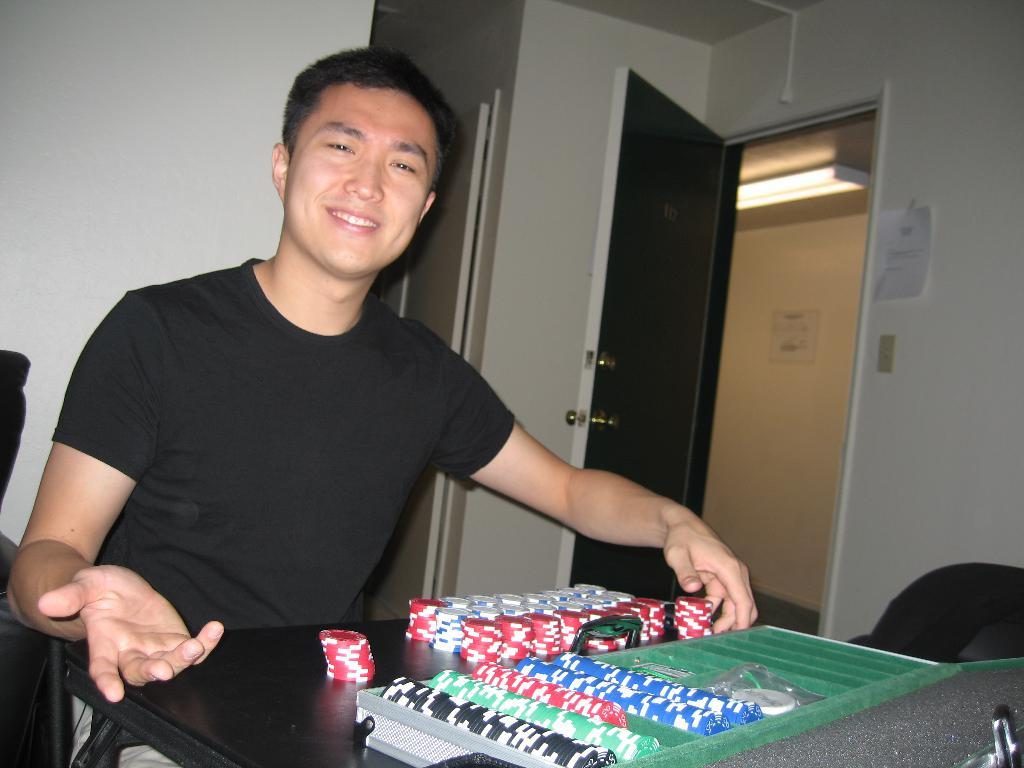Who is present in the image? There is a man in the image. What is the man doing in the image? The man is sitting and smiling. What can be seen on the table in the image? There are objects on the table. What is visible in the background of the image? There is a door and a wall visible in the image. What type of leather is visible on the man's apparel in the image? There is no leather visible on the man's apparel in the image. What type of vessel is present on the table in the image? There is no vessel present on the table in the image. 